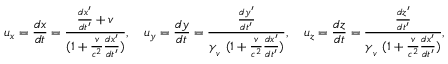Convert formula to latex. <formula><loc_0><loc_0><loc_500><loc_500>u _ { x } = { \frac { d x } { d t } } = { \frac { { \frac { d x ^ { \prime } } { d t ^ { \prime } } } + v } { ( 1 + { \frac { v } { c ^ { 2 } } } { \frac { d x ^ { \prime } } { d t ^ { \prime } } } ) } } , \quad u _ { y } = { \frac { d y } { d t } } = { \frac { \frac { d y ^ { \prime } } { d t ^ { \prime } } } { \gamma _ { _ { v } } \ ( 1 + { \frac { v } { c ^ { 2 } } } { \frac { d x ^ { \prime } } { d t ^ { \prime } } } ) } } , \quad u _ { z } = { \frac { d z } { d t } } = { \frac { \frac { d z ^ { \prime } } { d t ^ { \prime } } } { \gamma _ { _ { v } } \ ( 1 + { \frac { v } { c ^ { 2 } } } { \frac { d x ^ { \prime } } { d t ^ { \prime } } } ) } } ,</formula> 